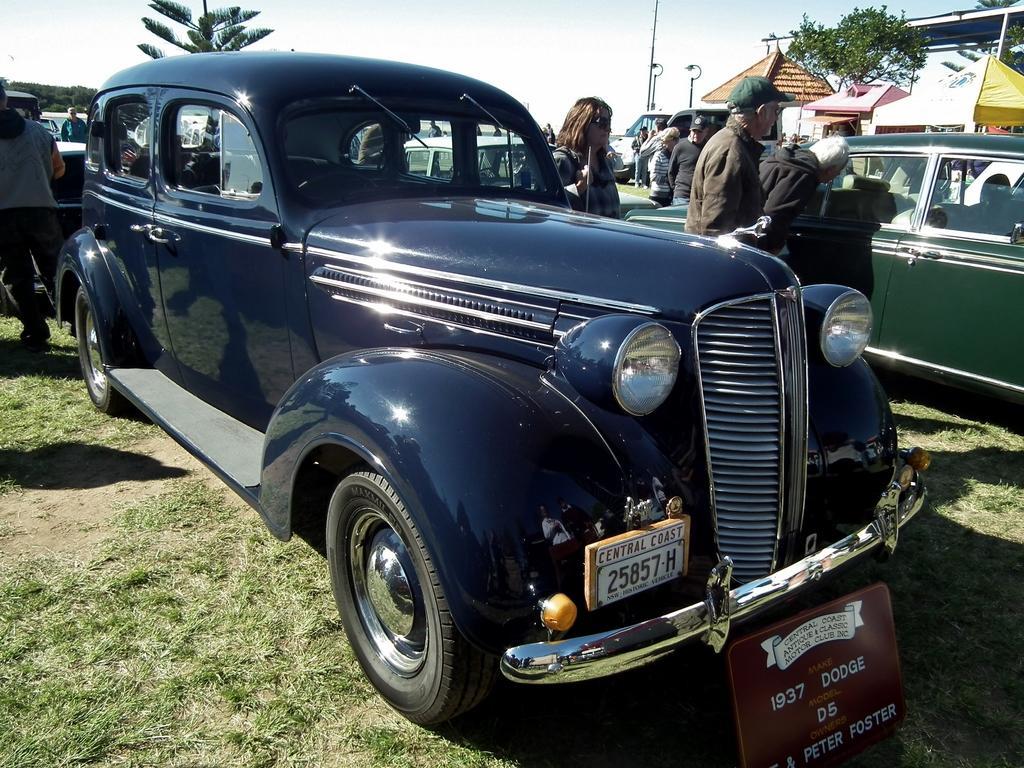Could you give a brief overview of what you see in this image? In this image I can see few vehicles, in front the vehicle is in blue color. Background I can also see few persons standing, trees in green color, few light poles and the sky is in white color. 